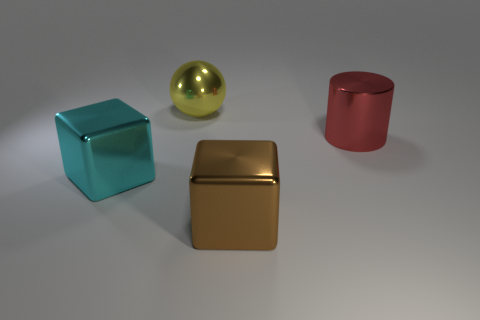The large sphere that is the same material as the large red object is what color? The large sphere in the image exhibits a reflective gold hue, consistent with the similarly shiny and metallic appearance of the larger cube-shaped object that has a rich golden color. 